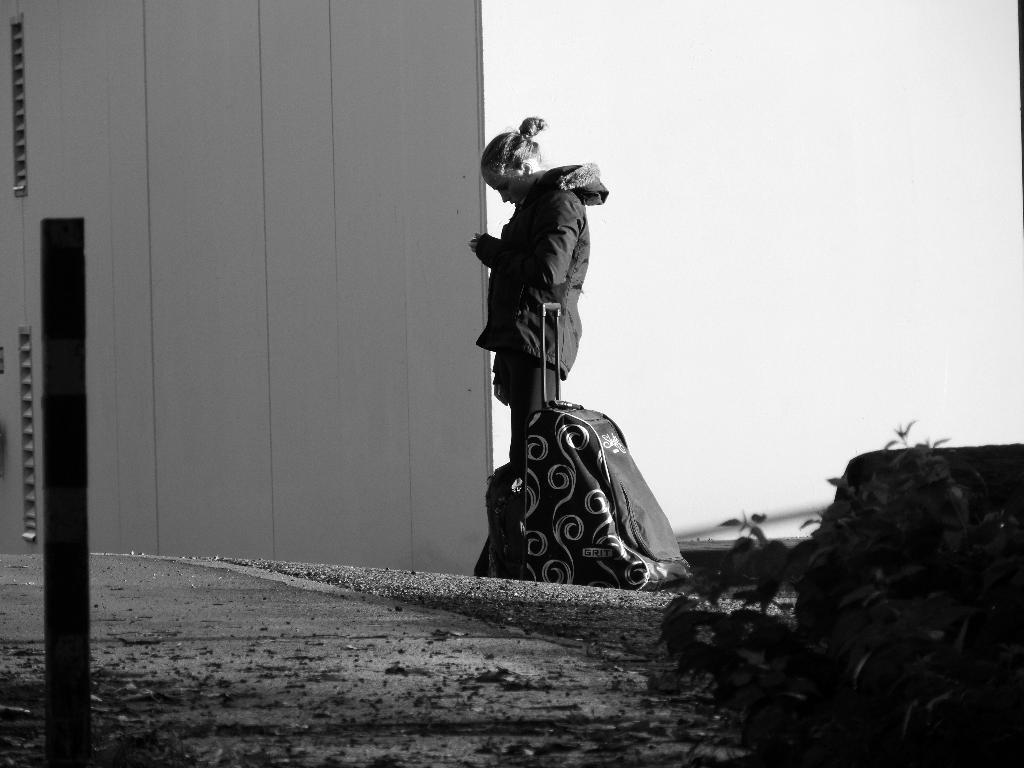What is the person in the image doing? The person is standing on the road. What object is beside the person? The person has a bag beside her. What is in front of the person? There is a wall in front of the person. What type of stitch is the person using to sew the ray in the image? There is no ray or sewing activity present in the image. 